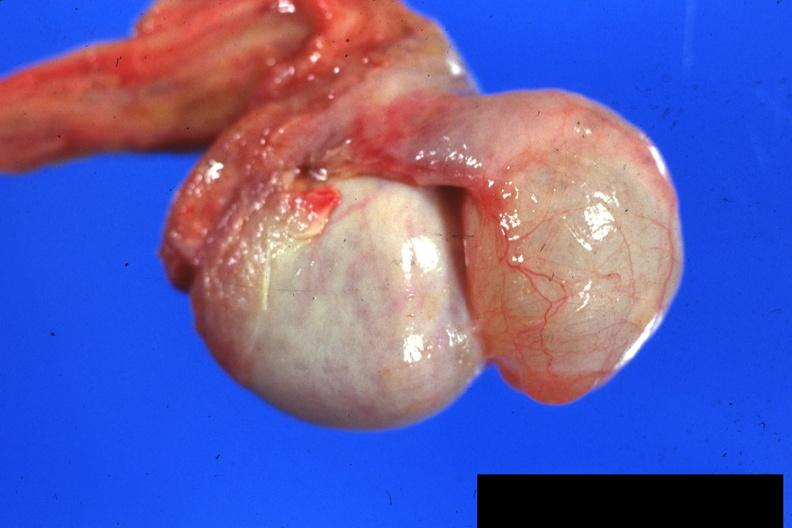s hydrocele present?
Answer the question using a single word or phrase. Yes 